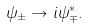<formula> <loc_0><loc_0><loc_500><loc_500>\psi _ { \pm } \to i \psi _ { \mp } ^ { * } .</formula> 